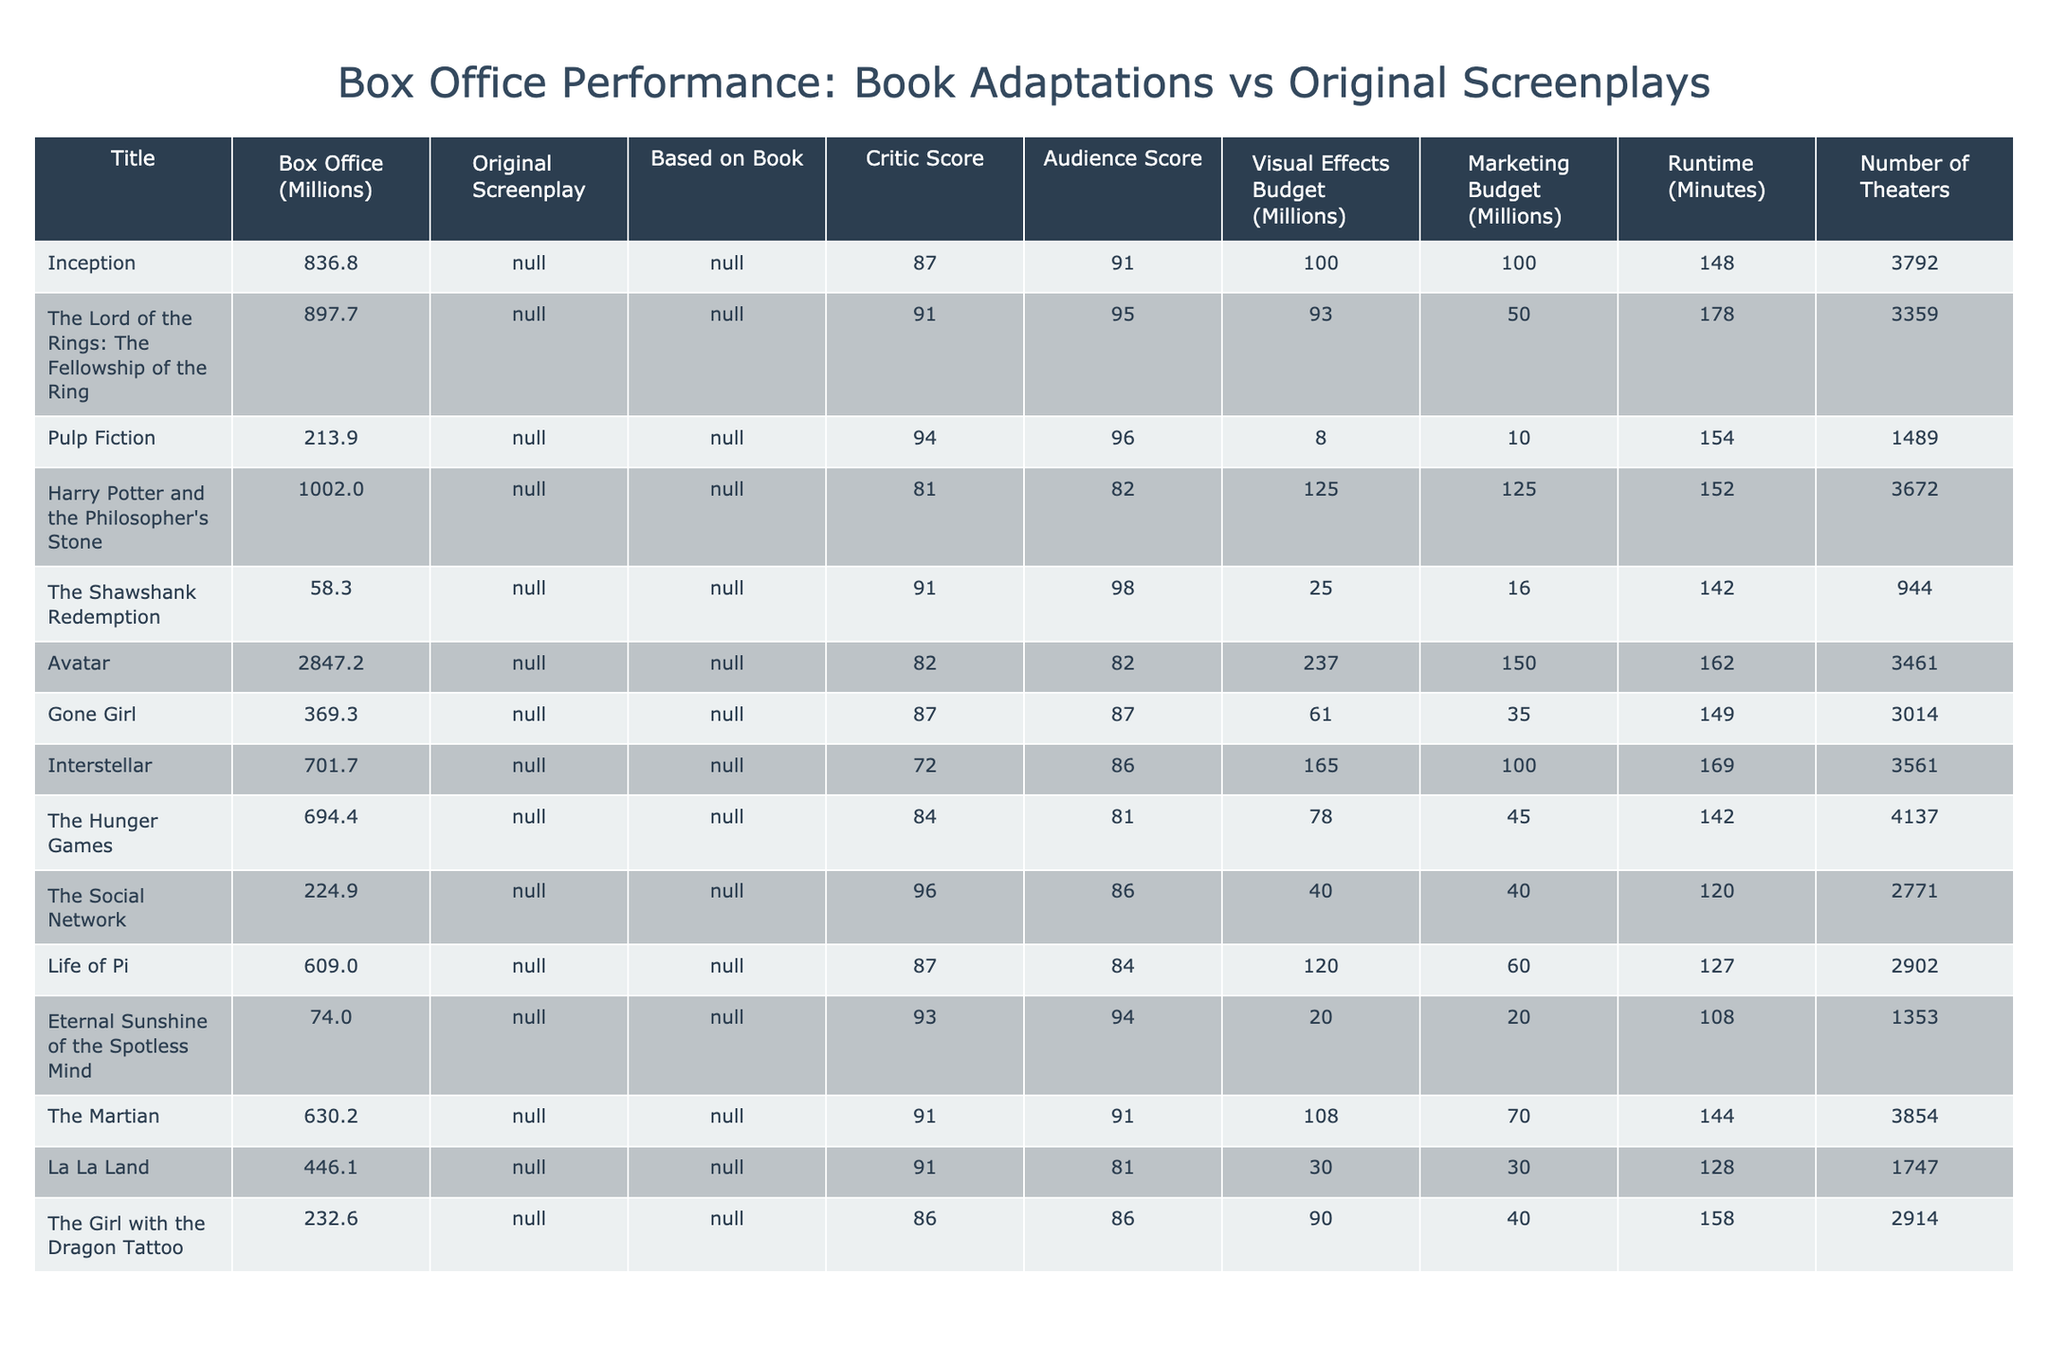What is the box office gross of "Avatar"? The table lists "Avatar" under the Title column with a corresponding value of 2847.2 million in the Box Office (Millions) column.
Answer: 2847.2 million How many movies in the table are original screenplays? The titles "Inception," "Pulp Fiction," "Interstellar," "The Social Network," "Eternal Sunshine of the Spotless Mind," and "La La Land" all have "Yes" under the Original Screenplay column, making a total of 6 movies.
Answer: 6 Which movie has the highest critic score? The Title "Pulp Fiction" has the highest Critic Score of 94, which is the maximum value listed in that column.
Answer: Pulp Fiction What is the average box office gross of the films based on books? Four films based on books listed are "The Lord of the Rings: The Fellowship of the Ring," "Harry Potter and the Philosopher's Stone," "Gone Girl," and "Life of Pi." Their box office values are 897.7, 1002.0, 369.3, and 609.0 million, respectively. The sum is 2878 million. Dividing by 4, the average is 719.5 million.
Answer: 719.5 million How much more did "Avatar" earn than the average box office of book adaptations? We previously calculated the average box office for book adaptations as 719.5 million. "Avatar" earned 2847.2 million. The difference is 2847.2 - 719.5 = 2127.7 million.
Answer: 2127.7 million Is "Harry Potter and the Philosopher's Stone" the highest-grossing movie based on a book? "Harry Potter and the Philosopher's Stone" has a box office of 1002.0 million, which is higher than the other book adaptations such as "The Lord of the Rings: The Fellowship of the Ring" (897.7 million), "Gone Girl" (369.3 million), and "Life of Pi" (609.0 million), confirming it as the highest.
Answer: Yes Which movie had the smallest marketing budget and what was it? The film "Pulp Fiction" has the smallest marketing budget of 10 million, as shown in the Marketing Budget column.
Answer: 10 million How many theaters screened "The Hunger Games"? The table shows that "The Hunger Games" was screened in 4137 theaters, as listed in the Number of Theaters column.
Answer: 4137 theaters What is the overall visual effects budget for all movies adapted from books? The visual effects budgets for book adaptations are 93, 125, 61, and 120 million for "The Lord of the Rings: The Fellowship of the Ring," "Harry Potter and the Philosopher's Stone," "Gone Girl," and "Life of Pi," respectively. Their total is 399 million.
Answer: 399 million Which film has the highest audience score among original screenplays? "Pulp Fiction" has an audience score of 96, which is higher than the other original screenplays like "Inception" (91), "Interstellar" (86), "The Social Network" (86), "Eternal Sunshine of the Spotless Mind" (94), and "La La Land" (81).
Answer: Pulp Fiction 